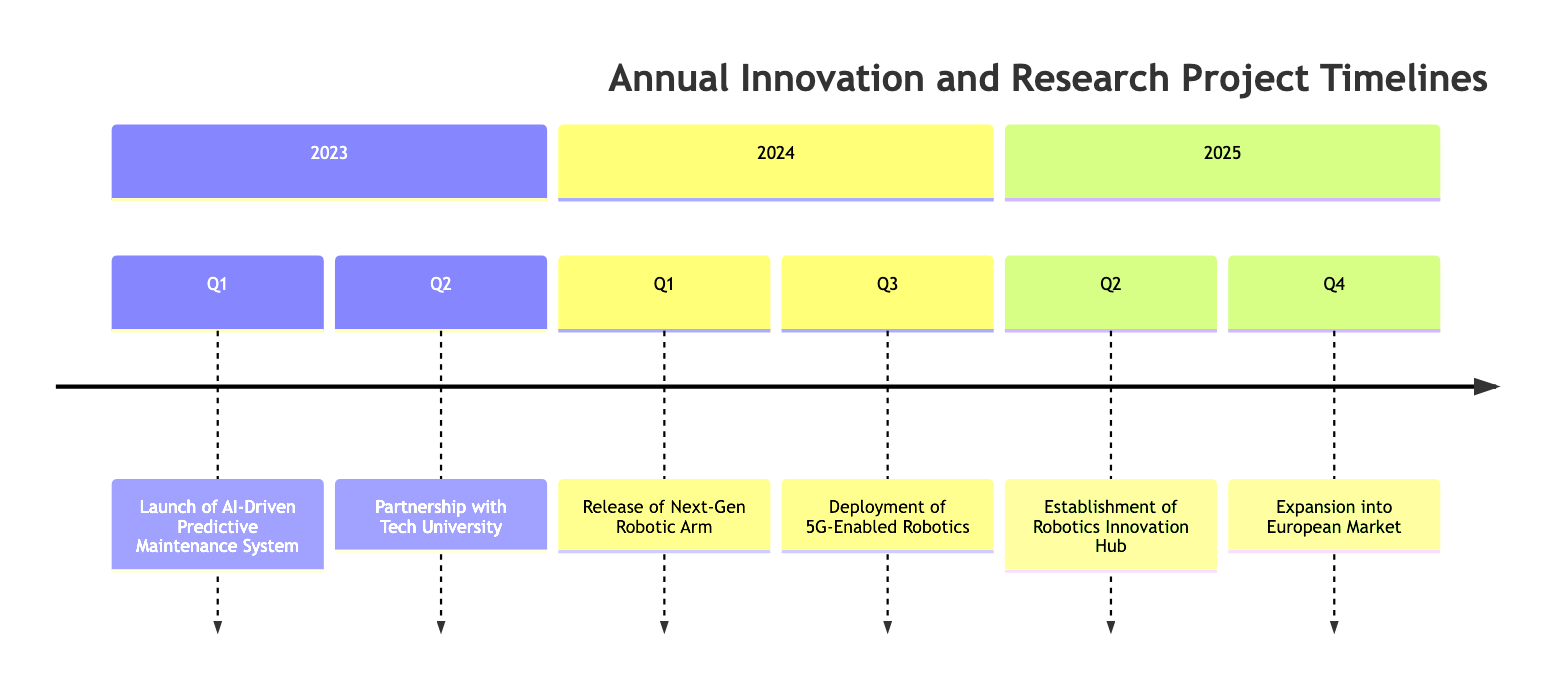What is the first milestone in 2023? The diagram shows a timeline with milestones for each year. For 2023, the first milestone is in Q1, which is "Launch of AI-Driven Predictive Maintenance System."
Answer: Launch of AI-Driven Predictive Maintenance System In which quarter is the "Deployment of 5G-Enabled Robotics"? The event "Deployment of 5G-Enabled Robotics" is located in the timeline specifically in Q3 of the year 2024.
Answer: Q3 How many total events are listed in the timeline? By counting the milestones across the provided years, there are a total of six events: two in 2023, two in 2024, and two in 2025.
Answer: 6 What is the last milestone listed in the timeline? The last milestone in the timeline is in Q4 of 2025, which is "Expansion into European Market."
Answer: Expansion into European Market Which year has the "Establishment of Robotics Innovation Hub" milestone? The event "Establishment of Robotics Innovation Hub" appears in the timeline specifically in Q2 of 2025.
Answer: 2025 Which event is associated with a partnership? The "Partnership with Tech University" event is specifically mentioned in Q2 of 2023 and is associated with collaboration for research.
Answer: Partnership with Tech University What does the next-generation robotic arm aim to improve on? The "Release of Next-Gen Robotic Arm" aims to be more efficient and versatile for complex assembly tasks according to its description in Q1 of 2024.
Answer: Efficiency and versatility In which year does the timeline indicate a focus on industry 4.0 solutions? The "Expansion into European Market" milestone specified for Q4 of 2025 indicates a focus on industry 4.0 solutions.
Answer: 2025 